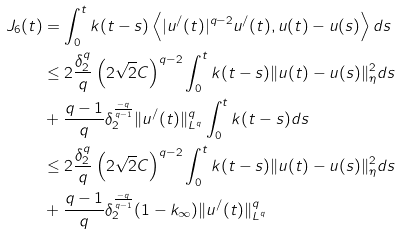<formula> <loc_0><loc_0><loc_500><loc_500>J _ { 6 } ( t ) & = \int _ { 0 } ^ { t } k ( t - s ) \left < | u ^ { / } ( t ) | ^ { q - 2 } u ^ { / } ( t ) , u ( t ) - u ( s ) \right > d s \\ & \leq 2 \frac { \delta _ { 2 } ^ { q } } { q } \left ( 2 \sqrt { 2 } C \right ) ^ { q - 2 } \int _ { 0 } ^ { t } k ( t - s ) \| u ( t ) - u ( s ) \| _ { \eta } ^ { 2 } d s \\ & + \frac { q - 1 } { q } \delta _ { 2 } ^ { \frac { - q } { q - 1 } } \| u ^ { / } ( t ) \| _ { L ^ { q } } ^ { q } \int _ { 0 } ^ { t } k ( t - s ) d s \\ & \leq 2 \frac { \delta _ { 2 } ^ { q } } { q } \left ( 2 \sqrt { 2 } C \right ) ^ { q - 2 } \int _ { 0 } ^ { t } k ( t - s ) \| u ( t ) - u ( s ) \| _ { \eta } ^ { 2 } d s \\ & + \frac { q - 1 } { q } \delta _ { 2 } ^ { \frac { - q } { q - 1 } } ( 1 - k _ { \infty } ) \| u ^ { / } ( t ) \| _ { L ^ { q } } ^ { q }</formula> 